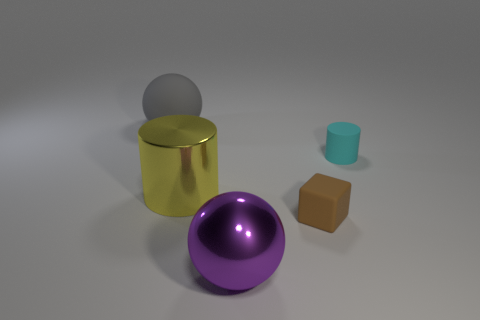Does the cylinder on the right side of the brown matte block have the same material as the purple object?
Your answer should be very brief. No. There is a cylinder that is on the right side of the large metallic object that is behind the sphere right of the large gray object; what is its material?
Offer a very short reply. Rubber. How many other objects are the same shape as the yellow metal thing?
Make the answer very short. 1. The big thing in front of the big yellow thing is what color?
Ensure brevity in your answer.  Purple. How many cylinders are on the right side of the sphere that is in front of the gray matte object left of the cyan rubber cylinder?
Your response must be concise. 1. What number of matte objects are in front of the ball that is in front of the large gray rubber object?
Offer a terse response. 0. How many matte things are on the right side of the rubber block?
Provide a short and direct response. 1. How many other things are the same size as the purple shiny ball?
Your answer should be compact. 2. The shiny thing that is the same shape as the big gray matte thing is what size?
Your answer should be compact. Large. The small cyan matte object that is right of the big purple sphere has what shape?
Make the answer very short. Cylinder. 